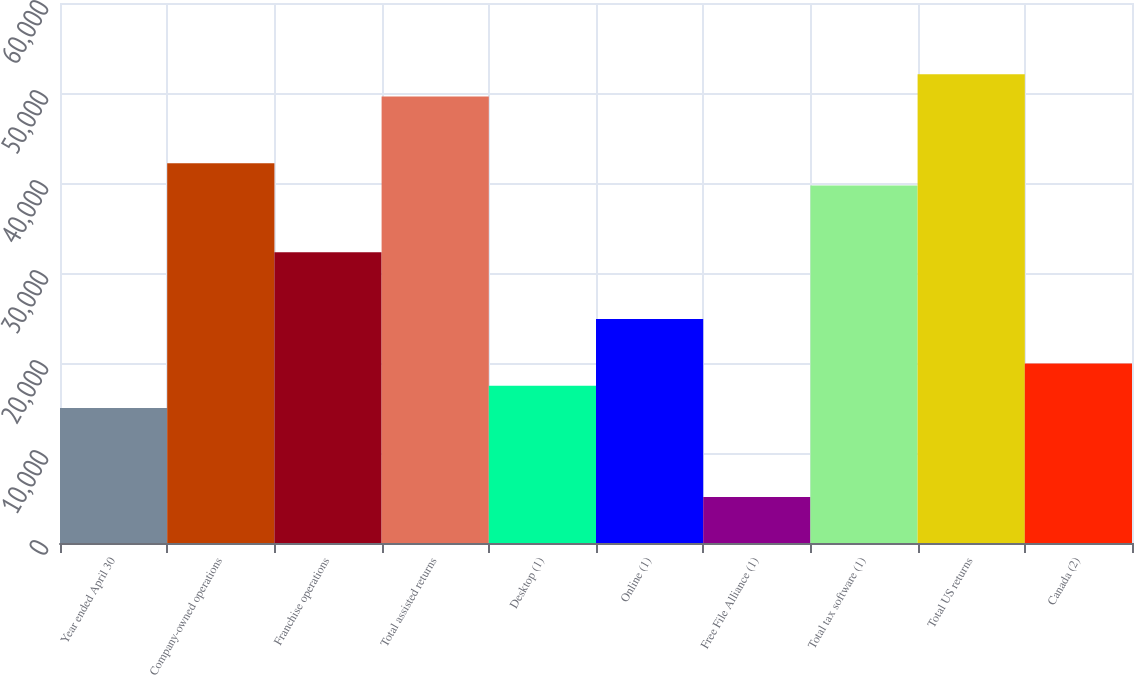<chart> <loc_0><loc_0><loc_500><loc_500><bar_chart><fcel>Year ended April 30<fcel>Company-owned operations<fcel>Franchise operations<fcel>Total assisted returns<fcel>Desktop (1)<fcel>Online (1)<fcel>Free File Alliance (1)<fcel>Total tax software (1)<fcel>Total US returns<fcel>Canada (2)<nl><fcel>15005.8<fcel>42195.6<fcel>32308.4<fcel>49611<fcel>17477.6<fcel>24893<fcel>5118.6<fcel>39723.8<fcel>52082.8<fcel>19949.4<nl></chart> 